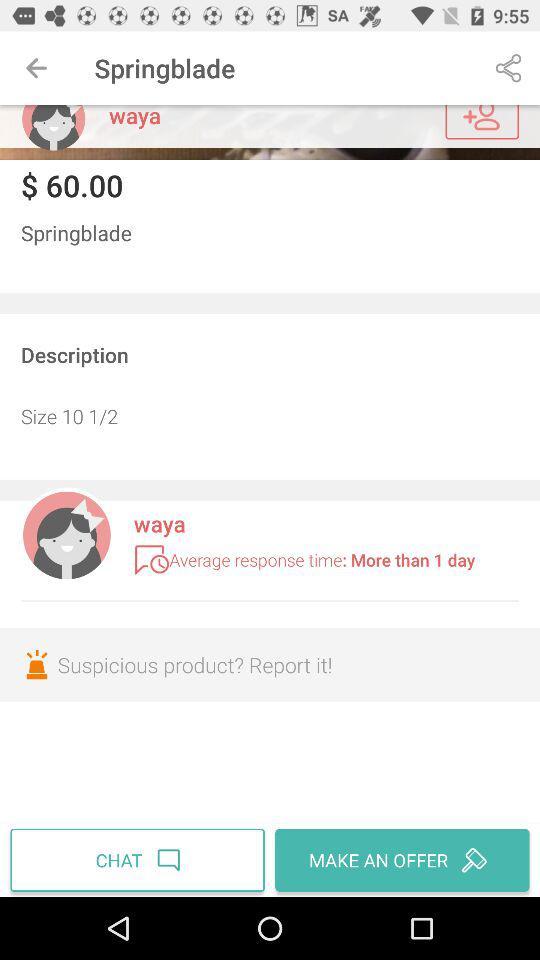How many days does it take for the seller to respond to messages?
Answer the question using a single word or phrase. More than 1 day 